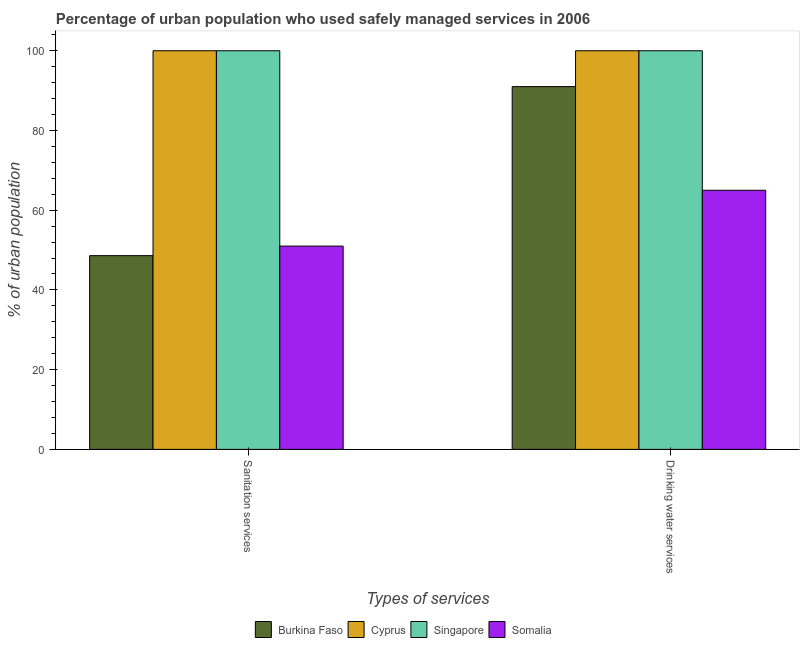How many groups of bars are there?
Your response must be concise. 2. How many bars are there on the 2nd tick from the left?
Ensure brevity in your answer.  4. What is the label of the 2nd group of bars from the left?
Your answer should be very brief. Drinking water services. Across all countries, what is the minimum percentage of urban population who used drinking water services?
Offer a terse response. 65. In which country was the percentage of urban population who used sanitation services maximum?
Ensure brevity in your answer.  Cyprus. In which country was the percentage of urban population who used sanitation services minimum?
Provide a succinct answer. Burkina Faso. What is the total percentage of urban population who used sanitation services in the graph?
Provide a short and direct response. 299.6. What is the difference between the percentage of urban population who used drinking water services in Somalia and that in Singapore?
Provide a short and direct response. -35. What is the average percentage of urban population who used sanitation services per country?
Your response must be concise. 74.9. What is the difference between the percentage of urban population who used sanitation services and percentage of urban population who used drinking water services in Burkina Faso?
Offer a very short reply. -42.4. What is the ratio of the percentage of urban population who used drinking water services in Somalia to that in Burkina Faso?
Offer a very short reply. 0.71. Is the percentage of urban population who used sanitation services in Cyprus less than that in Burkina Faso?
Offer a terse response. No. In how many countries, is the percentage of urban population who used drinking water services greater than the average percentage of urban population who used drinking water services taken over all countries?
Keep it short and to the point. 3. What does the 2nd bar from the left in Drinking water services represents?
Ensure brevity in your answer.  Cyprus. What does the 3rd bar from the right in Sanitation services represents?
Your response must be concise. Cyprus. What is the difference between two consecutive major ticks on the Y-axis?
Provide a short and direct response. 20. Does the graph contain any zero values?
Offer a terse response. No. How are the legend labels stacked?
Your answer should be very brief. Horizontal. What is the title of the graph?
Offer a very short reply. Percentage of urban population who used safely managed services in 2006. Does "Portugal" appear as one of the legend labels in the graph?
Make the answer very short. No. What is the label or title of the X-axis?
Provide a succinct answer. Types of services. What is the label or title of the Y-axis?
Provide a short and direct response. % of urban population. What is the % of urban population of Burkina Faso in Sanitation services?
Keep it short and to the point. 48.6. What is the % of urban population in Somalia in Sanitation services?
Give a very brief answer. 51. What is the % of urban population of Burkina Faso in Drinking water services?
Offer a terse response. 91. What is the % of urban population in Cyprus in Drinking water services?
Ensure brevity in your answer.  100. What is the % of urban population in Singapore in Drinking water services?
Your answer should be very brief. 100. What is the % of urban population in Somalia in Drinking water services?
Ensure brevity in your answer.  65. Across all Types of services, what is the maximum % of urban population in Burkina Faso?
Ensure brevity in your answer.  91. Across all Types of services, what is the maximum % of urban population of Singapore?
Make the answer very short. 100. Across all Types of services, what is the maximum % of urban population of Somalia?
Your answer should be compact. 65. Across all Types of services, what is the minimum % of urban population in Burkina Faso?
Offer a terse response. 48.6. Across all Types of services, what is the minimum % of urban population in Somalia?
Provide a succinct answer. 51. What is the total % of urban population in Burkina Faso in the graph?
Your response must be concise. 139.6. What is the total % of urban population of Cyprus in the graph?
Make the answer very short. 200. What is the total % of urban population of Somalia in the graph?
Provide a short and direct response. 116. What is the difference between the % of urban population of Burkina Faso in Sanitation services and that in Drinking water services?
Your answer should be very brief. -42.4. What is the difference between the % of urban population of Burkina Faso in Sanitation services and the % of urban population of Cyprus in Drinking water services?
Offer a very short reply. -51.4. What is the difference between the % of urban population in Burkina Faso in Sanitation services and the % of urban population in Singapore in Drinking water services?
Offer a terse response. -51.4. What is the difference between the % of urban population in Burkina Faso in Sanitation services and the % of urban population in Somalia in Drinking water services?
Make the answer very short. -16.4. What is the difference between the % of urban population of Cyprus in Sanitation services and the % of urban population of Somalia in Drinking water services?
Make the answer very short. 35. What is the average % of urban population in Burkina Faso per Types of services?
Ensure brevity in your answer.  69.8. What is the average % of urban population of Singapore per Types of services?
Your answer should be very brief. 100. What is the difference between the % of urban population in Burkina Faso and % of urban population in Cyprus in Sanitation services?
Keep it short and to the point. -51.4. What is the difference between the % of urban population in Burkina Faso and % of urban population in Singapore in Sanitation services?
Give a very brief answer. -51.4. What is the difference between the % of urban population of Burkina Faso and % of urban population of Somalia in Sanitation services?
Keep it short and to the point. -2.4. What is the difference between the % of urban population in Cyprus and % of urban population in Singapore in Sanitation services?
Keep it short and to the point. 0. What is the difference between the % of urban population in Cyprus and % of urban population in Somalia in Sanitation services?
Provide a succinct answer. 49. What is the difference between the % of urban population of Burkina Faso and % of urban population of Singapore in Drinking water services?
Keep it short and to the point. -9. What is the difference between the % of urban population of Singapore and % of urban population of Somalia in Drinking water services?
Your answer should be very brief. 35. What is the ratio of the % of urban population in Burkina Faso in Sanitation services to that in Drinking water services?
Provide a succinct answer. 0.53. What is the ratio of the % of urban population in Singapore in Sanitation services to that in Drinking water services?
Provide a short and direct response. 1. What is the ratio of the % of urban population in Somalia in Sanitation services to that in Drinking water services?
Your answer should be compact. 0.78. What is the difference between the highest and the second highest % of urban population in Burkina Faso?
Provide a short and direct response. 42.4. What is the difference between the highest and the lowest % of urban population in Burkina Faso?
Your response must be concise. 42.4. What is the difference between the highest and the lowest % of urban population in Singapore?
Your answer should be very brief. 0. 